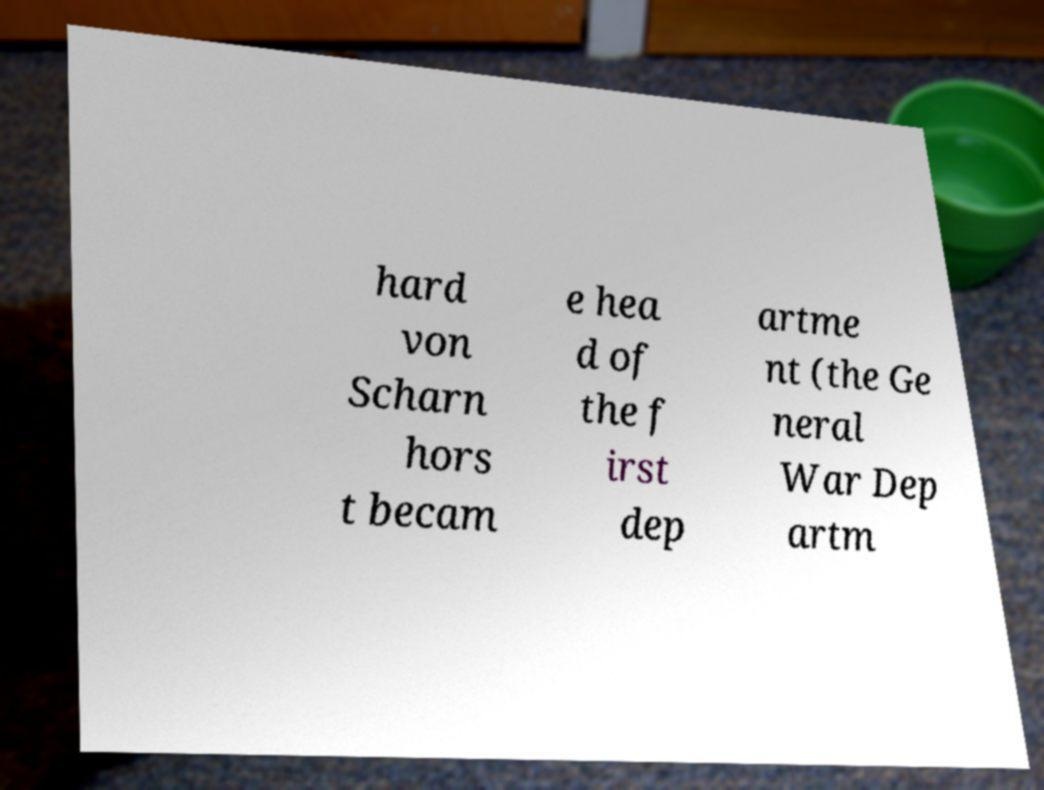There's text embedded in this image that I need extracted. Can you transcribe it verbatim? hard von Scharn hors t becam e hea d of the f irst dep artme nt (the Ge neral War Dep artm 